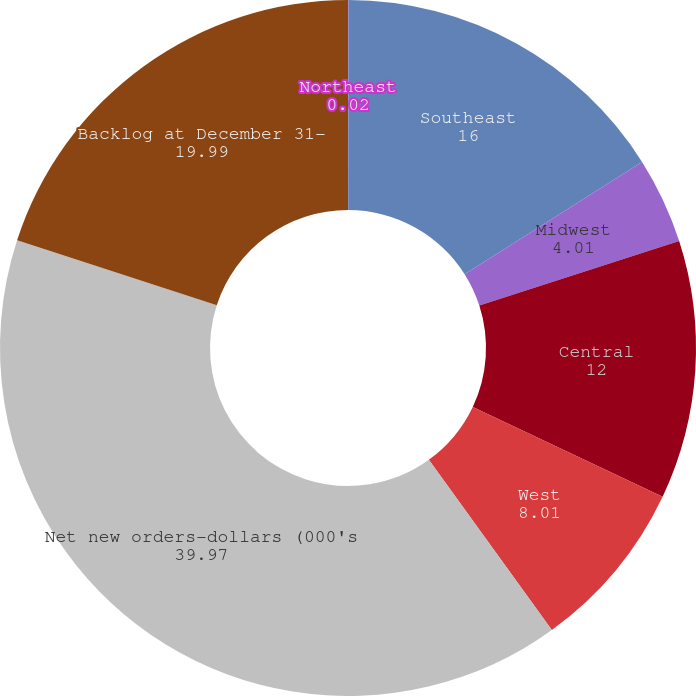Convert chart. <chart><loc_0><loc_0><loc_500><loc_500><pie_chart><fcel>Northeast<fcel>Southeast<fcel>Midwest<fcel>Central<fcel>West<fcel>Net new orders-dollars (000's<fcel>Backlog at December 31-<nl><fcel>0.02%<fcel>16.0%<fcel>4.01%<fcel>12.0%<fcel>8.01%<fcel>39.97%<fcel>19.99%<nl></chart> 